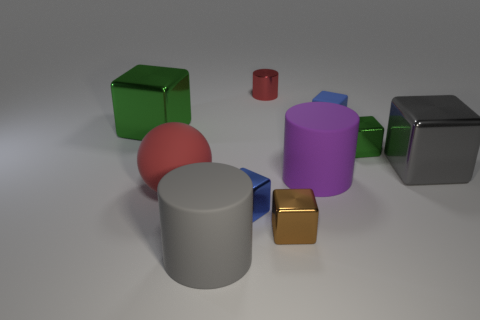Subtract all blue cubes. How many cubes are left? 4 Subtract all metal cylinders. How many cylinders are left? 2 Subtract all cylinders. How many objects are left? 7 Subtract 2 cubes. How many cubes are left? 4 Subtract all brown metal cubes. Subtract all large red rubber things. How many objects are left? 8 Add 2 big gray cubes. How many big gray cubes are left? 3 Add 4 large purple matte cylinders. How many large purple matte cylinders exist? 5 Subtract 1 brown cubes. How many objects are left? 9 Subtract all red blocks. Subtract all blue cylinders. How many blocks are left? 6 Subtract all yellow balls. How many purple cylinders are left? 1 